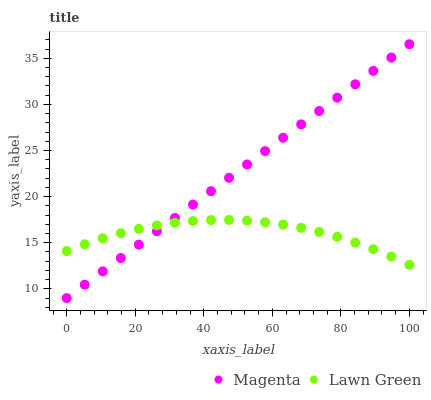Does Lawn Green have the minimum area under the curve?
Answer yes or no. Yes. Does Magenta have the maximum area under the curve?
Answer yes or no. Yes. Does Magenta have the minimum area under the curve?
Answer yes or no. No. Is Magenta the smoothest?
Answer yes or no. Yes. Is Lawn Green the roughest?
Answer yes or no. Yes. Is Magenta the roughest?
Answer yes or no. No. Does Magenta have the lowest value?
Answer yes or no. Yes. Does Magenta have the highest value?
Answer yes or no. Yes. Does Magenta intersect Lawn Green?
Answer yes or no. Yes. Is Magenta less than Lawn Green?
Answer yes or no. No. Is Magenta greater than Lawn Green?
Answer yes or no. No. 